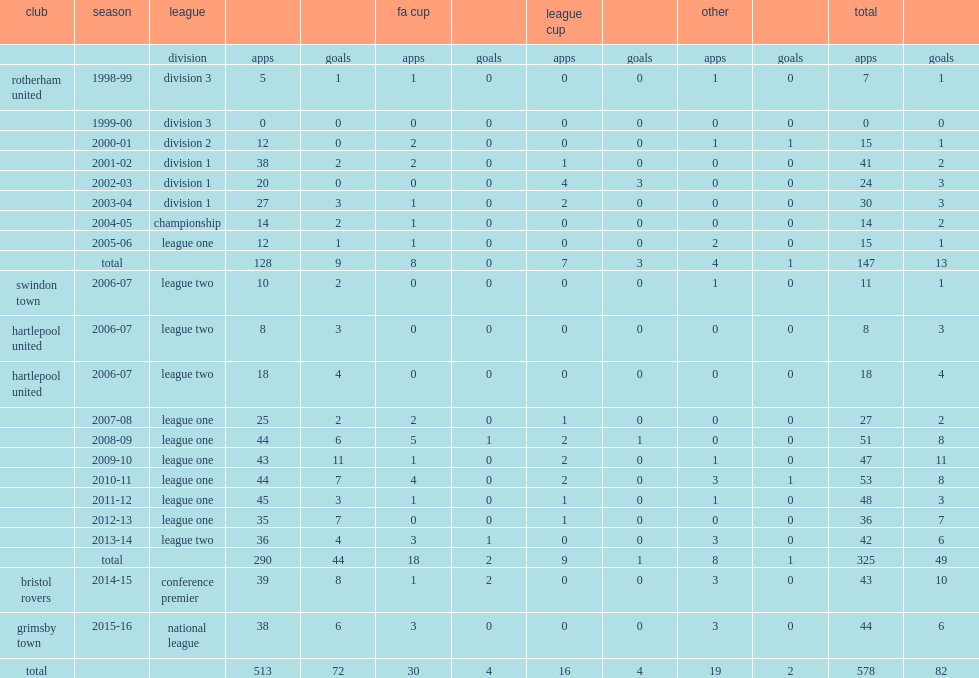How many league outings were for rotherham? 128.0. 